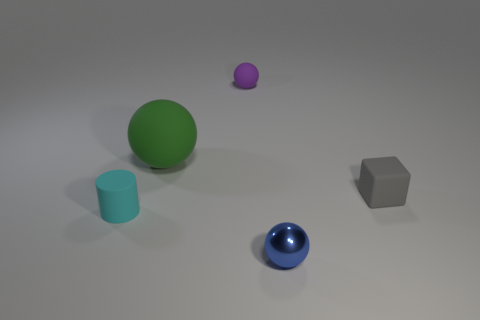Subtract all small purple balls. How many balls are left? 2 Add 1 small purple matte balls. How many objects exist? 6 Subtract all green balls. How many balls are left? 2 Subtract 1 balls. How many balls are left? 2 Subtract all balls. How many objects are left? 2 Subtract all green spheres. Subtract all purple cylinders. How many spheres are left? 2 Subtract all green cubes. How many gray cylinders are left? 0 Subtract all small rubber blocks. Subtract all cyan objects. How many objects are left? 3 Add 4 blue things. How many blue things are left? 5 Add 2 large red objects. How many large red objects exist? 2 